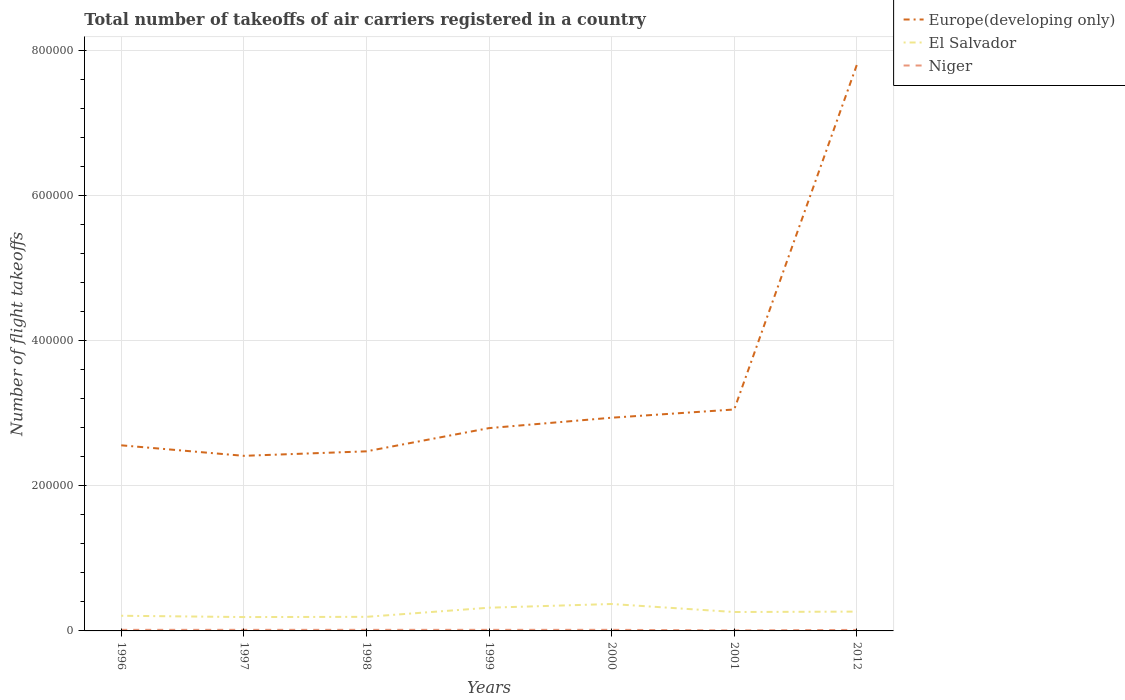Is the number of lines equal to the number of legend labels?
Keep it short and to the point. Yes. Across all years, what is the maximum total number of flight takeoffs in El Salvador?
Ensure brevity in your answer.  1.91e+04. In which year was the total number of flight takeoffs in Europe(developing only) maximum?
Keep it short and to the point. 1997. What is the total total number of flight takeoffs in Europe(developing only) in the graph?
Make the answer very short. -4.86e+05. What is the difference between the highest and the second highest total number of flight takeoffs in Europe(developing only)?
Provide a short and direct response. 5.39e+05. Is the total number of flight takeoffs in Europe(developing only) strictly greater than the total number of flight takeoffs in Niger over the years?
Offer a very short reply. No. Are the values on the major ticks of Y-axis written in scientific E-notation?
Provide a succinct answer. No. Does the graph contain any zero values?
Offer a terse response. No. Does the graph contain grids?
Give a very brief answer. Yes. How are the legend labels stacked?
Provide a short and direct response. Vertical. What is the title of the graph?
Provide a succinct answer. Total number of takeoffs of air carriers registered in a country. Does "Costa Rica" appear as one of the legend labels in the graph?
Ensure brevity in your answer.  No. What is the label or title of the X-axis?
Provide a succinct answer. Years. What is the label or title of the Y-axis?
Give a very brief answer. Number of flight takeoffs. What is the Number of flight takeoffs of Europe(developing only) in 1996?
Make the answer very short. 2.56e+05. What is the Number of flight takeoffs in El Salvador in 1996?
Ensure brevity in your answer.  2.09e+04. What is the Number of flight takeoffs of Niger in 1996?
Keep it short and to the point. 1500. What is the Number of flight takeoffs of Europe(developing only) in 1997?
Provide a succinct answer. 2.41e+05. What is the Number of flight takeoffs of El Salvador in 1997?
Keep it short and to the point. 1.91e+04. What is the Number of flight takeoffs in Niger in 1997?
Provide a short and direct response. 1500. What is the Number of flight takeoffs of Europe(developing only) in 1998?
Your answer should be compact. 2.48e+05. What is the Number of flight takeoffs in El Salvador in 1998?
Provide a succinct answer. 1.94e+04. What is the Number of flight takeoffs in Niger in 1998?
Give a very brief answer. 1500. What is the Number of flight takeoffs in Europe(developing only) in 1999?
Your response must be concise. 2.80e+05. What is the Number of flight takeoffs of El Salvador in 1999?
Make the answer very short. 3.20e+04. What is the Number of flight takeoffs of Niger in 1999?
Offer a terse response. 1500. What is the Number of flight takeoffs of Europe(developing only) in 2000?
Your answer should be very brief. 2.94e+05. What is the Number of flight takeoffs of El Salvador in 2000?
Keep it short and to the point. 3.71e+04. What is the Number of flight takeoffs in Niger in 2000?
Offer a terse response. 1518. What is the Number of flight takeoffs in Europe(developing only) in 2001?
Keep it short and to the point. 3.05e+05. What is the Number of flight takeoffs of El Salvador in 2001?
Ensure brevity in your answer.  2.61e+04. What is the Number of flight takeoffs of Niger in 2001?
Provide a succinct answer. 716. What is the Number of flight takeoffs of Europe(developing only) in 2012?
Make the answer very short. 7.80e+05. What is the Number of flight takeoffs in El Salvador in 2012?
Your response must be concise. 2.66e+04. What is the Number of flight takeoffs of Niger in 2012?
Offer a terse response. 1416. Across all years, what is the maximum Number of flight takeoffs in Europe(developing only)?
Ensure brevity in your answer.  7.80e+05. Across all years, what is the maximum Number of flight takeoffs of El Salvador?
Offer a very short reply. 3.71e+04. Across all years, what is the maximum Number of flight takeoffs in Niger?
Make the answer very short. 1518. Across all years, what is the minimum Number of flight takeoffs in Europe(developing only)?
Your response must be concise. 2.41e+05. Across all years, what is the minimum Number of flight takeoffs in El Salvador?
Your answer should be compact. 1.91e+04. Across all years, what is the minimum Number of flight takeoffs in Niger?
Make the answer very short. 716. What is the total Number of flight takeoffs in Europe(developing only) in the graph?
Your response must be concise. 2.40e+06. What is the total Number of flight takeoffs of El Salvador in the graph?
Your response must be concise. 1.81e+05. What is the total Number of flight takeoffs of Niger in the graph?
Ensure brevity in your answer.  9650. What is the difference between the Number of flight takeoffs in Europe(developing only) in 1996 and that in 1997?
Your answer should be compact. 1.45e+04. What is the difference between the Number of flight takeoffs of El Salvador in 1996 and that in 1997?
Your answer should be very brief. 1800. What is the difference between the Number of flight takeoffs in Niger in 1996 and that in 1997?
Ensure brevity in your answer.  0. What is the difference between the Number of flight takeoffs in Europe(developing only) in 1996 and that in 1998?
Your answer should be compact. 8300. What is the difference between the Number of flight takeoffs in El Salvador in 1996 and that in 1998?
Keep it short and to the point. 1500. What is the difference between the Number of flight takeoffs of Niger in 1996 and that in 1998?
Your response must be concise. 0. What is the difference between the Number of flight takeoffs in Europe(developing only) in 1996 and that in 1999?
Ensure brevity in your answer.  -2.37e+04. What is the difference between the Number of flight takeoffs of El Salvador in 1996 and that in 1999?
Offer a terse response. -1.11e+04. What is the difference between the Number of flight takeoffs of Niger in 1996 and that in 1999?
Offer a terse response. 0. What is the difference between the Number of flight takeoffs in Europe(developing only) in 1996 and that in 2000?
Your answer should be compact. -3.80e+04. What is the difference between the Number of flight takeoffs of El Salvador in 1996 and that in 2000?
Provide a succinct answer. -1.62e+04. What is the difference between the Number of flight takeoffs of Niger in 1996 and that in 2000?
Your response must be concise. -18. What is the difference between the Number of flight takeoffs of Europe(developing only) in 1996 and that in 2001?
Give a very brief answer. -4.94e+04. What is the difference between the Number of flight takeoffs of El Salvador in 1996 and that in 2001?
Ensure brevity in your answer.  -5159. What is the difference between the Number of flight takeoffs of Niger in 1996 and that in 2001?
Your response must be concise. 784. What is the difference between the Number of flight takeoffs in Europe(developing only) in 1996 and that in 2012?
Your response must be concise. -5.24e+05. What is the difference between the Number of flight takeoffs in El Salvador in 1996 and that in 2012?
Ensure brevity in your answer.  -5722. What is the difference between the Number of flight takeoffs of Niger in 1996 and that in 2012?
Provide a succinct answer. 84. What is the difference between the Number of flight takeoffs in Europe(developing only) in 1997 and that in 1998?
Your answer should be compact. -6200. What is the difference between the Number of flight takeoffs of El Salvador in 1997 and that in 1998?
Give a very brief answer. -300. What is the difference between the Number of flight takeoffs of Europe(developing only) in 1997 and that in 1999?
Ensure brevity in your answer.  -3.82e+04. What is the difference between the Number of flight takeoffs in El Salvador in 1997 and that in 1999?
Your answer should be very brief. -1.29e+04. What is the difference between the Number of flight takeoffs in Europe(developing only) in 1997 and that in 2000?
Your answer should be very brief. -5.25e+04. What is the difference between the Number of flight takeoffs in El Salvador in 1997 and that in 2000?
Keep it short and to the point. -1.80e+04. What is the difference between the Number of flight takeoffs in Europe(developing only) in 1997 and that in 2001?
Provide a short and direct response. -6.39e+04. What is the difference between the Number of flight takeoffs of El Salvador in 1997 and that in 2001?
Provide a succinct answer. -6959. What is the difference between the Number of flight takeoffs in Niger in 1997 and that in 2001?
Your answer should be very brief. 784. What is the difference between the Number of flight takeoffs in Europe(developing only) in 1997 and that in 2012?
Provide a short and direct response. -5.39e+05. What is the difference between the Number of flight takeoffs of El Salvador in 1997 and that in 2012?
Give a very brief answer. -7522. What is the difference between the Number of flight takeoffs of Europe(developing only) in 1998 and that in 1999?
Offer a very short reply. -3.20e+04. What is the difference between the Number of flight takeoffs of El Salvador in 1998 and that in 1999?
Provide a short and direct response. -1.26e+04. What is the difference between the Number of flight takeoffs of Europe(developing only) in 1998 and that in 2000?
Provide a short and direct response. -4.63e+04. What is the difference between the Number of flight takeoffs in El Salvador in 1998 and that in 2000?
Make the answer very short. -1.77e+04. What is the difference between the Number of flight takeoffs of Niger in 1998 and that in 2000?
Give a very brief answer. -18. What is the difference between the Number of flight takeoffs in Europe(developing only) in 1998 and that in 2001?
Provide a succinct answer. -5.77e+04. What is the difference between the Number of flight takeoffs in El Salvador in 1998 and that in 2001?
Keep it short and to the point. -6659. What is the difference between the Number of flight takeoffs in Niger in 1998 and that in 2001?
Provide a short and direct response. 784. What is the difference between the Number of flight takeoffs of Europe(developing only) in 1998 and that in 2012?
Give a very brief answer. -5.33e+05. What is the difference between the Number of flight takeoffs of El Salvador in 1998 and that in 2012?
Offer a very short reply. -7222. What is the difference between the Number of flight takeoffs in Niger in 1998 and that in 2012?
Give a very brief answer. 84. What is the difference between the Number of flight takeoffs of Europe(developing only) in 1999 and that in 2000?
Give a very brief answer. -1.43e+04. What is the difference between the Number of flight takeoffs in El Salvador in 1999 and that in 2000?
Offer a terse response. -5098. What is the difference between the Number of flight takeoffs in Europe(developing only) in 1999 and that in 2001?
Keep it short and to the point. -2.57e+04. What is the difference between the Number of flight takeoffs of El Salvador in 1999 and that in 2001?
Your response must be concise. 5941. What is the difference between the Number of flight takeoffs in Niger in 1999 and that in 2001?
Offer a very short reply. 784. What is the difference between the Number of flight takeoffs of Europe(developing only) in 1999 and that in 2012?
Offer a terse response. -5.01e+05. What is the difference between the Number of flight takeoffs in El Salvador in 1999 and that in 2012?
Your answer should be compact. 5378. What is the difference between the Number of flight takeoffs in Europe(developing only) in 2000 and that in 2001?
Ensure brevity in your answer.  -1.13e+04. What is the difference between the Number of flight takeoffs of El Salvador in 2000 and that in 2001?
Ensure brevity in your answer.  1.10e+04. What is the difference between the Number of flight takeoffs in Niger in 2000 and that in 2001?
Provide a short and direct response. 802. What is the difference between the Number of flight takeoffs in Europe(developing only) in 2000 and that in 2012?
Give a very brief answer. -4.86e+05. What is the difference between the Number of flight takeoffs of El Salvador in 2000 and that in 2012?
Offer a very short reply. 1.05e+04. What is the difference between the Number of flight takeoffs of Niger in 2000 and that in 2012?
Ensure brevity in your answer.  102. What is the difference between the Number of flight takeoffs in Europe(developing only) in 2001 and that in 2012?
Make the answer very short. -4.75e+05. What is the difference between the Number of flight takeoffs in El Salvador in 2001 and that in 2012?
Keep it short and to the point. -563. What is the difference between the Number of flight takeoffs in Niger in 2001 and that in 2012?
Your answer should be compact. -700. What is the difference between the Number of flight takeoffs in Europe(developing only) in 1996 and the Number of flight takeoffs in El Salvador in 1997?
Provide a short and direct response. 2.37e+05. What is the difference between the Number of flight takeoffs in Europe(developing only) in 1996 and the Number of flight takeoffs in Niger in 1997?
Offer a terse response. 2.54e+05. What is the difference between the Number of flight takeoffs of El Salvador in 1996 and the Number of flight takeoffs of Niger in 1997?
Offer a very short reply. 1.94e+04. What is the difference between the Number of flight takeoffs in Europe(developing only) in 1996 and the Number of flight takeoffs in El Salvador in 1998?
Make the answer very short. 2.36e+05. What is the difference between the Number of flight takeoffs in Europe(developing only) in 1996 and the Number of flight takeoffs in Niger in 1998?
Ensure brevity in your answer.  2.54e+05. What is the difference between the Number of flight takeoffs of El Salvador in 1996 and the Number of flight takeoffs of Niger in 1998?
Make the answer very short. 1.94e+04. What is the difference between the Number of flight takeoffs in Europe(developing only) in 1996 and the Number of flight takeoffs in El Salvador in 1999?
Make the answer very short. 2.24e+05. What is the difference between the Number of flight takeoffs in Europe(developing only) in 1996 and the Number of flight takeoffs in Niger in 1999?
Offer a terse response. 2.54e+05. What is the difference between the Number of flight takeoffs in El Salvador in 1996 and the Number of flight takeoffs in Niger in 1999?
Make the answer very short. 1.94e+04. What is the difference between the Number of flight takeoffs in Europe(developing only) in 1996 and the Number of flight takeoffs in El Salvador in 2000?
Your answer should be compact. 2.19e+05. What is the difference between the Number of flight takeoffs in Europe(developing only) in 1996 and the Number of flight takeoffs in Niger in 2000?
Your answer should be compact. 2.54e+05. What is the difference between the Number of flight takeoffs in El Salvador in 1996 and the Number of flight takeoffs in Niger in 2000?
Give a very brief answer. 1.94e+04. What is the difference between the Number of flight takeoffs in Europe(developing only) in 1996 and the Number of flight takeoffs in El Salvador in 2001?
Offer a very short reply. 2.30e+05. What is the difference between the Number of flight takeoffs in Europe(developing only) in 1996 and the Number of flight takeoffs in Niger in 2001?
Your answer should be compact. 2.55e+05. What is the difference between the Number of flight takeoffs of El Salvador in 1996 and the Number of flight takeoffs of Niger in 2001?
Your response must be concise. 2.02e+04. What is the difference between the Number of flight takeoffs in Europe(developing only) in 1996 and the Number of flight takeoffs in El Salvador in 2012?
Your response must be concise. 2.29e+05. What is the difference between the Number of flight takeoffs in Europe(developing only) in 1996 and the Number of flight takeoffs in Niger in 2012?
Keep it short and to the point. 2.54e+05. What is the difference between the Number of flight takeoffs in El Salvador in 1996 and the Number of flight takeoffs in Niger in 2012?
Offer a very short reply. 1.95e+04. What is the difference between the Number of flight takeoffs of Europe(developing only) in 1997 and the Number of flight takeoffs of El Salvador in 1998?
Your answer should be compact. 2.22e+05. What is the difference between the Number of flight takeoffs of Europe(developing only) in 1997 and the Number of flight takeoffs of Niger in 1998?
Give a very brief answer. 2.40e+05. What is the difference between the Number of flight takeoffs in El Salvador in 1997 and the Number of flight takeoffs in Niger in 1998?
Offer a terse response. 1.76e+04. What is the difference between the Number of flight takeoffs in Europe(developing only) in 1997 and the Number of flight takeoffs in El Salvador in 1999?
Offer a very short reply. 2.09e+05. What is the difference between the Number of flight takeoffs in Europe(developing only) in 1997 and the Number of flight takeoffs in Niger in 1999?
Your response must be concise. 2.40e+05. What is the difference between the Number of flight takeoffs of El Salvador in 1997 and the Number of flight takeoffs of Niger in 1999?
Your answer should be compact. 1.76e+04. What is the difference between the Number of flight takeoffs in Europe(developing only) in 1997 and the Number of flight takeoffs in El Salvador in 2000?
Ensure brevity in your answer.  2.04e+05. What is the difference between the Number of flight takeoffs of Europe(developing only) in 1997 and the Number of flight takeoffs of Niger in 2000?
Offer a very short reply. 2.40e+05. What is the difference between the Number of flight takeoffs of El Salvador in 1997 and the Number of flight takeoffs of Niger in 2000?
Your answer should be very brief. 1.76e+04. What is the difference between the Number of flight takeoffs of Europe(developing only) in 1997 and the Number of flight takeoffs of El Salvador in 2001?
Ensure brevity in your answer.  2.15e+05. What is the difference between the Number of flight takeoffs of Europe(developing only) in 1997 and the Number of flight takeoffs of Niger in 2001?
Offer a terse response. 2.41e+05. What is the difference between the Number of flight takeoffs of El Salvador in 1997 and the Number of flight takeoffs of Niger in 2001?
Offer a terse response. 1.84e+04. What is the difference between the Number of flight takeoffs of Europe(developing only) in 1997 and the Number of flight takeoffs of El Salvador in 2012?
Your answer should be very brief. 2.15e+05. What is the difference between the Number of flight takeoffs of Europe(developing only) in 1997 and the Number of flight takeoffs of Niger in 2012?
Keep it short and to the point. 2.40e+05. What is the difference between the Number of flight takeoffs in El Salvador in 1997 and the Number of flight takeoffs in Niger in 2012?
Your answer should be compact. 1.77e+04. What is the difference between the Number of flight takeoffs of Europe(developing only) in 1998 and the Number of flight takeoffs of El Salvador in 1999?
Your answer should be compact. 2.16e+05. What is the difference between the Number of flight takeoffs of Europe(developing only) in 1998 and the Number of flight takeoffs of Niger in 1999?
Keep it short and to the point. 2.46e+05. What is the difference between the Number of flight takeoffs of El Salvador in 1998 and the Number of flight takeoffs of Niger in 1999?
Provide a short and direct response. 1.79e+04. What is the difference between the Number of flight takeoffs of Europe(developing only) in 1998 and the Number of flight takeoffs of El Salvador in 2000?
Offer a terse response. 2.10e+05. What is the difference between the Number of flight takeoffs of Europe(developing only) in 1998 and the Number of flight takeoffs of Niger in 2000?
Offer a very short reply. 2.46e+05. What is the difference between the Number of flight takeoffs of El Salvador in 1998 and the Number of flight takeoffs of Niger in 2000?
Your response must be concise. 1.79e+04. What is the difference between the Number of flight takeoffs of Europe(developing only) in 1998 and the Number of flight takeoffs of El Salvador in 2001?
Keep it short and to the point. 2.21e+05. What is the difference between the Number of flight takeoffs in Europe(developing only) in 1998 and the Number of flight takeoffs in Niger in 2001?
Ensure brevity in your answer.  2.47e+05. What is the difference between the Number of flight takeoffs in El Salvador in 1998 and the Number of flight takeoffs in Niger in 2001?
Offer a terse response. 1.87e+04. What is the difference between the Number of flight takeoffs of Europe(developing only) in 1998 and the Number of flight takeoffs of El Salvador in 2012?
Provide a succinct answer. 2.21e+05. What is the difference between the Number of flight takeoffs in Europe(developing only) in 1998 and the Number of flight takeoffs in Niger in 2012?
Provide a short and direct response. 2.46e+05. What is the difference between the Number of flight takeoffs in El Salvador in 1998 and the Number of flight takeoffs in Niger in 2012?
Keep it short and to the point. 1.80e+04. What is the difference between the Number of flight takeoffs in Europe(developing only) in 1999 and the Number of flight takeoffs in El Salvador in 2000?
Give a very brief answer. 2.42e+05. What is the difference between the Number of flight takeoffs in Europe(developing only) in 1999 and the Number of flight takeoffs in Niger in 2000?
Your response must be concise. 2.78e+05. What is the difference between the Number of flight takeoffs in El Salvador in 1999 and the Number of flight takeoffs in Niger in 2000?
Your answer should be compact. 3.05e+04. What is the difference between the Number of flight takeoffs of Europe(developing only) in 1999 and the Number of flight takeoffs of El Salvador in 2001?
Make the answer very short. 2.53e+05. What is the difference between the Number of flight takeoffs in Europe(developing only) in 1999 and the Number of flight takeoffs in Niger in 2001?
Your response must be concise. 2.79e+05. What is the difference between the Number of flight takeoffs in El Salvador in 1999 and the Number of flight takeoffs in Niger in 2001?
Your response must be concise. 3.13e+04. What is the difference between the Number of flight takeoffs of Europe(developing only) in 1999 and the Number of flight takeoffs of El Salvador in 2012?
Give a very brief answer. 2.53e+05. What is the difference between the Number of flight takeoffs of Europe(developing only) in 1999 and the Number of flight takeoffs of Niger in 2012?
Your answer should be very brief. 2.78e+05. What is the difference between the Number of flight takeoffs in El Salvador in 1999 and the Number of flight takeoffs in Niger in 2012?
Offer a very short reply. 3.06e+04. What is the difference between the Number of flight takeoffs of Europe(developing only) in 2000 and the Number of flight takeoffs of El Salvador in 2001?
Offer a terse response. 2.68e+05. What is the difference between the Number of flight takeoffs of Europe(developing only) in 2000 and the Number of flight takeoffs of Niger in 2001?
Offer a very short reply. 2.93e+05. What is the difference between the Number of flight takeoffs of El Salvador in 2000 and the Number of flight takeoffs of Niger in 2001?
Ensure brevity in your answer.  3.64e+04. What is the difference between the Number of flight takeoffs in Europe(developing only) in 2000 and the Number of flight takeoffs in El Salvador in 2012?
Offer a very short reply. 2.67e+05. What is the difference between the Number of flight takeoffs of Europe(developing only) in 2000 and the Number of flight takeoffs of Niger in 2012?
Ensure brevity in your answer.  2.92e+05. What is the difference between the Number of flight takeoffs in El Salvador in 2000 and the Number of flight takeoffs in Niger in 2012?
Offer a very short reply. 3.57e+04. What is the difference between the Number of flight takeoffs in Europe(developing only) in 2001 and the Number of flight takeoffs in El Salvador in 2012?
Make the answer very short. 2.79e+05. What is the difference between the Number of flight takeoffs of Europe(developing only) in 2001 and the Number of flight takeoffs of Niger in 2012?
Give a very brief answer. 3.04e+05. What is the difference between the Number of flight takeoffs in El Salvador in 2001 and the Number of flight takeoffs in Niger in 2012?
Make the answer very short. 2.46e+04. What is the average Number of flight takeoffs of Europe(developing only) per year?
Provide a short and direct response. 3.43e+05. What is the average Number of flight takeoffs of El Salvador per year?
Provide a succinct answer. 2.59e+04. What is the average Number of flight takeoffs in Niger per year?
Your answer should be very brief. 1378.57. In the year 1996, what is the difference between the Number of flight takeoffs in Europe(developing only) and Number of flight takeoffs in El Salvador?
Ensure brevity in your answer.  2.35e+05. In the year 1996, what is the difference between the Number of flight takeoffs of Europe(developing only) and Number of flight takeoffs of Niger?
Keep it short and to the point. 2.54e+05. In the year 1996, what is the difference between the Number of flight takeoffs of El Salvador and Number of flight takeoffs of Niger?
Make the answer very short. 1.94e+04. In the year 1997, what is the difference between the Number of flight takeoffs in Europe(developing only) and Number of flight takeoffs in El Salvador?
Your response must be concise. 2.22e+05. In the year 1997, what is the difference between the Number of flight takeoffs in Europe(developing only) and Number of flight takeoffs in Niger?
Offer a terse response. 2.40e+05. In the year 1997, what is the difference between the Number of flight takeoffs in El Salvador and Number of flight takeoffs in Niger?
Give a very brief answer. 1.76e+04. In the year 1998, what is the difference between the Number of flight takeoffs in Europe(developing only) and Number of flight takeoffs in El Salvador?
Make the answer very short. 2.28e+05. In the year 1998, what is the difference between the Number of flight takeoffs of Europe(developing only) and Number of flight takeoffs of Niger?
Provide a succinct answer. 2.46e+05. In the year 1998, what is the difference between the Number of flight takeoffs in El Salvador and Number of flight takeoffs in Niger?
Offer a terse response. 1.79e+04. In the year 1999, what is the difference between the Number of flight takeoffs of Europe(developing only) and Number of flight takeoffs of El Salvador?
Your answer should be very brief. 2.48e+05. In the year 1999, what is the difference between the Number of flight takeoffs in Europe(developing only) and Number of flight takeoffs in Niger?
Keep it short and to the point. 2.78e+05. In the year 1999, what is the difference between the Number of flight takeoffs in El Salvador and Number of flight takeoffs in Niger?
Make the answer very short. 3.05e+04. In the year 2000, what is the difference between the Number of flight takeoffs in Europe(developing only) and Number of flight takeoffs in El Salvador?
Provide a succinct answer. 2.57e+05. In the year 2000, what is the difference between the Number of flight takeoffs of Europe(developing only) and Number of flight takeoffs of Niger?
Your answer should be compact. 2.92e+05. In the year 2000, what is the difference between the Number of flight takeoffs of El Salvador and Number of flight takeoffs of Niger?
Ensure brevity in your answer.  3.56e+04. In the year 2001, what is the difference between the Number of flight takeoffs in Europe(developing only) and Number of flight takeoffs in El Salvador?
Offer a terse response. 2.79e+05. In the year 2001, what is the difference between the Number of flight takeoffs in Europe(developing only) and Number of flight takeoffs in Niger?
Make the answer very short. 3.04e+05. In the year 2001, what is the difference between the Number of flight takeoffs in El Salvador and Number of flight takeoffs in Niger?
Give a very brief answer. 2.53e+04. In the year 2012, what is the difference between the Number of flight takeoffs of Europe(developing only) and Number of flight takeoffs of El Salvador?
Give a very brief answer. 7.53e+05. In the year 2012, what is the difference between the Number of flight takeoffs in Europe(developing only) and Number of flight takeoffs in Niger?
Your answer should be very brief. 7.79e+05. In the year 2012, what is the difference between the Number of flight takeoffs of El Salvador and Number of flight takeoffs of Niger?
Give a very brief answer. 2.52e+04. What is the ratio of the Number of flight takeoffs of Europe(developing only) in 1996 to that in 1997?
Offer a terse response. 1.06. What is the ratio of the Number of flight takeoffs in El Salvador in 1996 to that in 1997?
Give a very brief answer. 1.09. What is the ratio of the Number of flight takeoffs in Europe(developing only) in 1996 to that in 1998?
Your answer should be very brief. 1.03. What is the ratio of the Number of flight takeoffs in El Salvador in 1996 to that in 1998?
Provide a succinct answer. 1.08. What is the ratio of the Number of flight takeoffs in Niger in 1996 to that in 1998?
Keep it short and to the point. 1. What is the ratio of the Number of flight takeoffs in Europe(developing only) in 1996 to that in 1999?
Offer a very short reply. 0.92. What is the ratio of the Number of flight takeoffs of El Salvador in 1996 to that in 1999?
Provide a succinct answer. 0.65. What is the ratio of the Number of flight takeoffs in Europe(developing only) in 1996 to that in 2000?
Your answer should be very brief. 0.87. What is the ratio of the Number of flight takeoffs of El Salvador in 1996 to that in 2000?
Give a very brief answer. 0.56. What is the ratio of the Number of flight takeoffs in Europe(developing only) in 1996 to that in 2001?
Give a very brief answer. 0.84. What is the ratio of the Number of flight takeoffs of El Salvador in 1996 to that in 2001?
Your answer should be very brief. 0.8. What is the ratio of the Number of flight takeoffs of Niger in 1996 to that in 2001?
Make the answer very short. 2.1. What is the ratio of the Number of flight takeoffs of Europe(developing only) in 1996 to that in 2012?
Your answer should be very brief. 0.33. What is the ratio of the Number of flight takeoffs in El Salvador in 1996 to that in 2012?
Ensure brevity in your answer.  0.79. What is the ratio of the Number of flight takeoffs in Niger in 1996 to that in 2012?
Provide a short and direct response. 1.06. What is the ratio of the Number of flight takeoffs in Europe(developing only) in 1997 to that in 1998?
Keep it short and to the point. 0.97. What is the ratio of the Number of flight takeoffs of El Salvador in 1997 to that in 1998?
Ensure brevity in your answer.  0.98. What is the ratio of the Number of flight takeoffs of Niger in 1997 to that in 1998?
Offer a very short reply. 1. What is the ratio of the Number of flight takeoffs in Europe(developing only) in 1997 to that in 1999?
Keep it short and to the point. 0.86. What is the ratio of the Number of flight takeoffs in El Salvador in 1997 to that in 1999?
Give a very brief answer. 0.6. What is the ratio of the Number of flight takeoffs in Europe(developing only) in 1997 to that in 2000?
Provide a succinct answer. 0.82. What is the ratio of the Number of flight takeoffs of El Salvador in 1997 to that in 2000?
Keep it short and to the point. 0.51. What is the ratio of the Number of flight takeoffs of Europe(developing only) in 1997 to that in 2001?
Your response must be concise. 0.79. What is the ratio of the Number of flight takeoffs in El Salvador in 1997 to that in 2001?
Ensure brevity in your answer.  0.73. What is the ratio of the Number of flight takeoffs of Niger in 1997 to that in 2001?
Offer a terse response. 2.1. What is the ratio of the Number of flight takeoffs in Europe(developing only) in 1997 to that in 2012?
Offer a terse response. 0.31. What is the ratio of the Number of flight takeoffs in El Salvador in 1997 to that in 2012?
Ensure brevity in your answer.  0.72. What is the ratio of the Number of flight takeoffs in Niger in 1997 to that in 2012?
Keep it short and to the point. 1.06. What is the ratio of the Number of flight takeoffs in Europe(developing only) in 1998 to that in 1999?
Keep it short and to the point. 0.89. What is the ratio of the Number of flight takeoffs in El Salvador in 1998 to that in 1999?
Give a very brief answer. 0.61. What is the ratio of the Number of flight takeoffs of Niger in 1998 to that in 1999?
Provide a short and direct response. 1. What is the ratio of the Number of flight takeoffs of Europe(developing only) in 1998 to that in 2000?
Your answer should be very brief. 0.84. What is the ratio of the Number of flight takeoffs in El Salvador in 1998 to that in 2000?
Offer a very short reply. 0.52. What is the ratio of the Number of flight takeoffs of Europe(developing only) in 1998 to that in 2001?
Offer a very short reply. 0.81. What is the ratio of the Number of flight takeoffs in El Salvador in 1998 to that in 2001?
Provide a short and direct response. 0.74. What is the ratio of the Number of flight takeoffs of Niger in 1998 to that in 2001?
Keep it short and to the point. 2.1. What is the ratio of the Number of flight takeoffs in Europe(developing only) in 1998 to that in 2012?
Give a very brief answer. 0.32. What is the ratio of the Number of flight takeoffs of El Salvador in 1998 to that in 2012?
Make the answer very short. 0.73. What is the ratio of the Number of flight takeoffs of Niger in 1998 to that in 2012?
Offer a terse response. 1.06. What is the ratio of the Number of flight takeoffs in Europe(developing only) in 1999 to that in 2000?
Offer a terse response. 0.95. What is the ratio of the Number of flight takeoffs in El Salvador in 1999 to that in 2000?
Provide a short and direct response. 0.86. What is the ratio of the Number of flight takeoffs in Niger in 1999 to that in 2000?
Provide a short and direct response. 0.99. What is the ratio of the Number of flight takeoffs of Europe(developing only) in 1999 to that in 2001?
Give a very brief answer. 0.92. What is the ratio of the Number of flight takeoffs in El Salvador in 1999 to that in 2001?
Offer a very short reply. 1.23. What is the ratio of the Number of flight takeoffs of Niger in 1999 to that in 2001?
Provide a succinct answer. 2.1. What is the ratio of the Number of flight takeoffs in Europe(developing only) in 1999 to that in 2012?
Your response must be concise. 0.36. What is the ratio of the Number of flight takeoffs in El Salvador in 1999 to that in 2012?
Ensure brevity in your answer.  1.2. What is the ratio of the Number of flight takeoffs of Niger in 1999 to that in 2012?
Offer a terse response. 1.06. What is the ratio of the Number of flight takeoffs of Europe(developing only) in 2000 to that in 2001?
Offer a very short reply. 0.96. What is the ratio of the Number of flight takeoffs in El Salvador in 2000 to that in 2001?
Ensure brevity in your answer.  1.42. What is the ratio of the Number of flight takeoffs in Niger in 2000 to that in 2001?
Make the answer very short. 2.12. What is the ratio of the Number of flight takeoffs in Europe(developing only) in 2000 to that in 2012?
Offer a very short reply. 0.38. What is the ratio of the Number of flight takeoffs in El Salvador in 2000 to that in 2012?
Your answer should be very brief. 1.39. What is the ratio of the Number of flight takeoffs in Niger in 2000 to that in 2012?
Your response must be concise. 1.07. What is the ratio of the Number of flight takeoffs of Europe(developing only) in 2001 to that in 2012?
Provide a short and direct response. 0.39. What is the ratio of the Number of flight takeoffs in El Salvador in 2001 to that in 2012?
Offer a very short reply. 0.98. What is the ratio of the Number of flight takeoffs in Niger in 2001 to that in 2012?
Offer a terse response. 0.51. What is the difference between the highest and the second highest Number of flight takeoffs of Europe(developing only)?
Give a very brief answer. 4.75e+05. What is the difference between the highest and the second highest Number of flight takeoffs in El Salvador?
Offer a terse response. 5098. What is the difference between the highest and the lowest Number of flight takeoffs of Europe(developing only)?
Provide a short and direct response. 5.39e+05. What is the difference between the highest and the lowest Number of flight takeoffs of El Salvador?
Offer a very short reply. 1.80e+04. What is the difference between the highest and the lowest Number of flight takeoffs of Niger?
Your response must be concise. 802. 